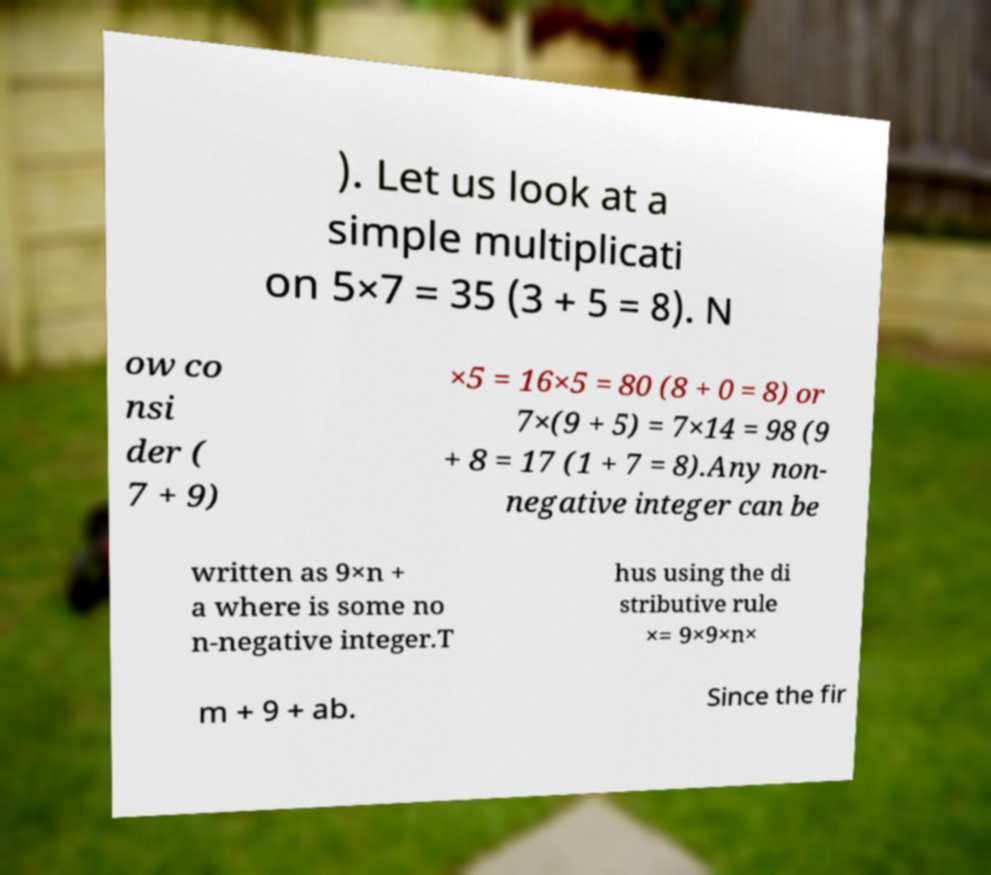For documentation purposes, I need the text within this image transcribed. Could you provide that? ). Let us look at a simple multiplicati on 5×7 = 35 (3 + 5 = 8). N ow co nsi der ( 7 + 9) ×5 = 16×5 = 80 (8 + 0 = 8) or 7×(9 + 5) = 7×14 = 98 (9 + 8 = 17 (1 + 7 = 8).Any non- negative integer can be written as 9×n + a where is some no n-negative integer.T hus using the di stributive rule ×= 9×9×n× m + 9 + ab. Since the fir 